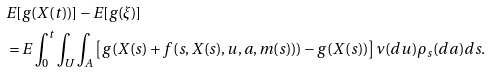Convert formula to latex. <formula><loc_0><loc_0><loc_500><loc_500>& E [ g ( X ( t ) ) ] - E [ g ( \xi ) ] \\ & = E \int _ { 0 } ^ { t } \int _ { U } \int _ { A } \left [ g ( X ( s ) + f ( s , X ( s ) , u , a , m ( s ) ) ) - g ( X ( s ) ) \right ] \nu ( d u ) \rho _ { s } ( d a ) d s .</formula> 